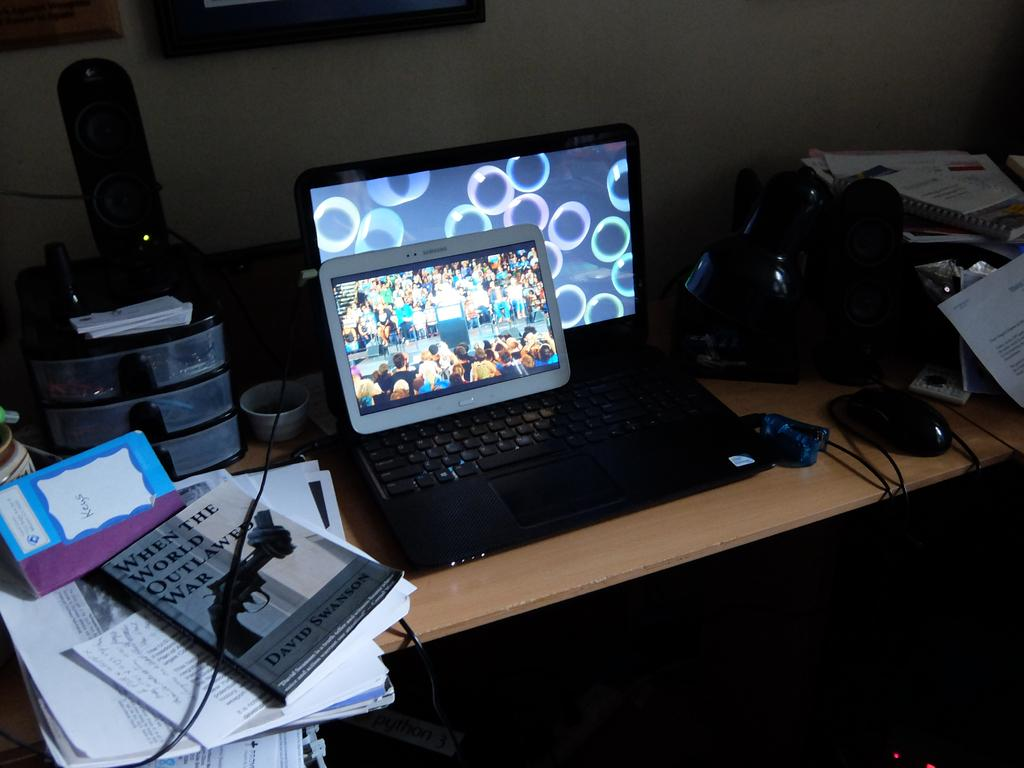What is the main piece of furniture in the image? There is a table in the image. What items can be seen on the table? Papers, a book, a speaker, a laptop, a tab, and a mouse are on the table. Can you describe any other objects on the table? There are other objects on the table, but their specific details are not mentioned in the facts. What can be seen in the background of the image? There is a wall and a photo frame in the background. What type of debt is being discussed in the image? There is no mention of debt in the image, as it primarily focuses on the table and its contents. 